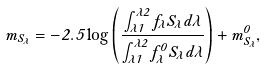Convert formula to latex. <formula><loc_0><loc_0><loc_500><loc_500>m _ { S _ { \lambda } } = - 2 . 5 \log \left ( \frac { \int _ { \lambda 1 } ^ { \lambda 2 } f _ { \lambda } S _ { \lambda } d \lambda } { \int _ { \lambda 1 } ^ { \lambda 2 } f _ { \lambda } ^ { 0 } S _ { \lambda } d \lambda } \right ) + m _ { S _ { \lambda } } ^ { 0 } ,</formula> 